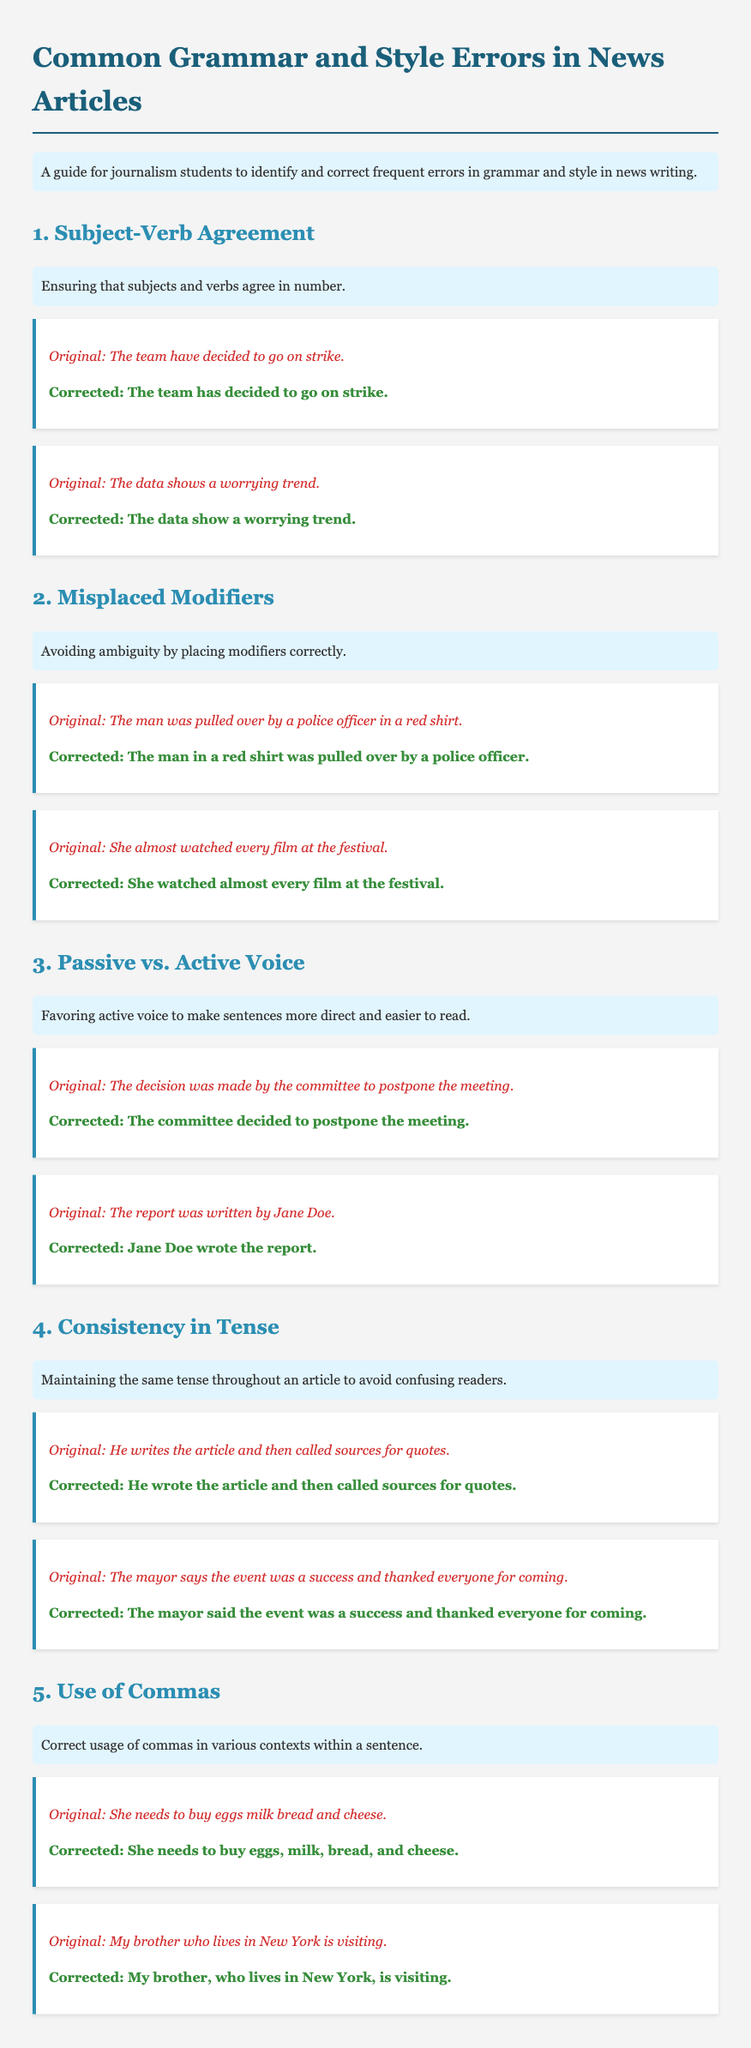What is the title of the document? The title of the document appears at the top, indicating the main topic covered.
Answer: Common Grammar and Style Errors in News Articles What is the first common error discussed? The first common error is highlighted as part of the structured content in the document.
Answer: Subject-Verb Agreement What does "The team have decided to go on strike" illustrate? This sentence serves as an example demonstrating the incorrect usage discussed initially.
Answer: Subject-Verb Agreement Which voice is favored for clarity in news articles? The document mentions a preference that affects the readability of sentences.
Answer: Active voice How many examples are provided for the use of commas? The count of the examples can be found by reviewing the section dedicated to commas.
Answer: 2 What does the phrase "The mayor says the event was a success" demonstrate? This sentence is included to exemplify a particular error in grammatical consistency.
Answer: Consistency in Tense What is the purpose of the example section in each error category? The examples help illustrate the grammatical error and its correction for clarity.
Answer: Provide corrections What type of errors does the guide specifically address? The content is focused on improving specific elements of writing in journalism.
Answer: Grammar and style errors 